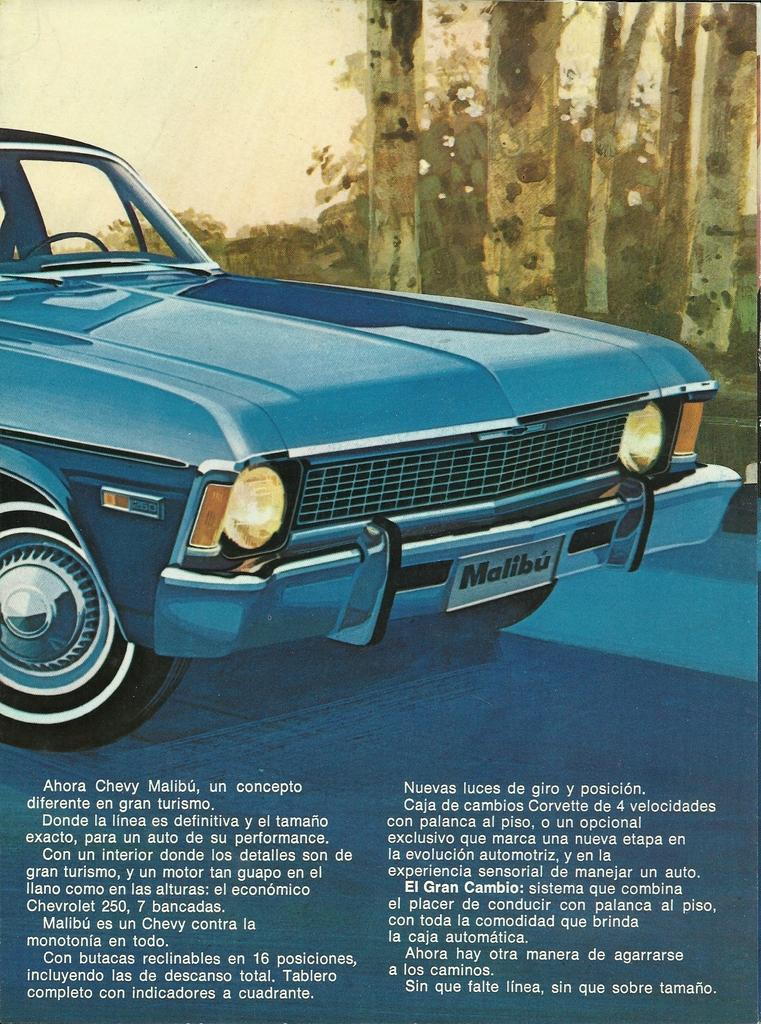What type of image is being described? The image is a poster. What is the main subject of the poster? There is a car in the center of the poster. Is there any text on the poster? Yes, there is text at the bottom of the poster. Can you see any ocean waves in the image? There is no ocean or waves present in the image; it features a car on a poster with text at the bottom. 